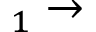Convert formula to latex. <formula><loc_0><loc_0><loc_500><loc_500>_ { 1 } \rightarrow</formula> 